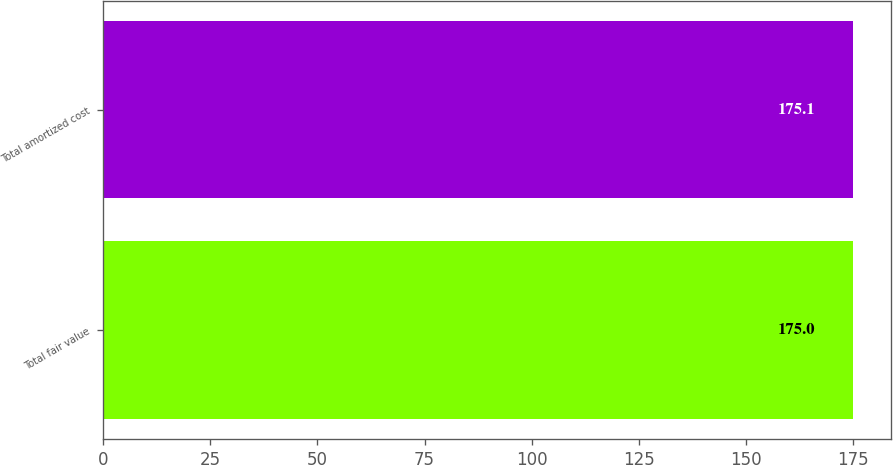Convert chart to OTSL. <chart><loc_0><loc_0><loc_500><loc_500><bar_chart><fcel>Total fair value<fcel>Total amortized cost<nl><fcel>175<fcel>175.1<nl></chart> 